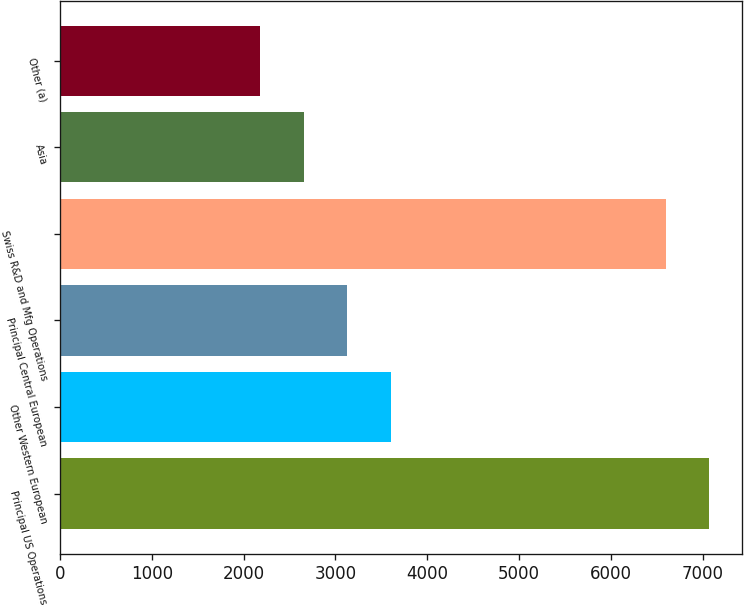<chart> <loc_0><loc_0><loc_500><loc_500><bar_chart><fcel>Principal US Operations<fcel>Other Western European<fcel>Principal Central European<fcel>Swiss R&D and Mfg Operations<fcel>Asia<fcel>Other (a)<nl><fcel>7070.7<fcel>3606.1<fcel>3130.4<fcel>6595<fcel>2654.7<fcel>2179<nl></chart> 